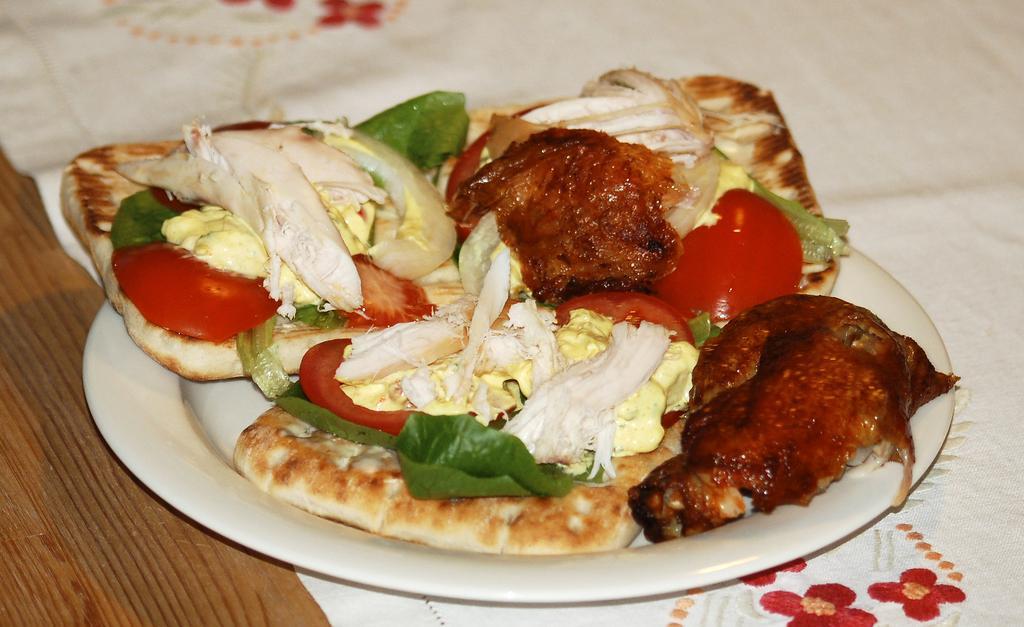In one or two sentences, can you explain what this image depicts? In the image on the wooden surface there is a cloth with a design on it. On the cloth there is a plate with food items in it. 